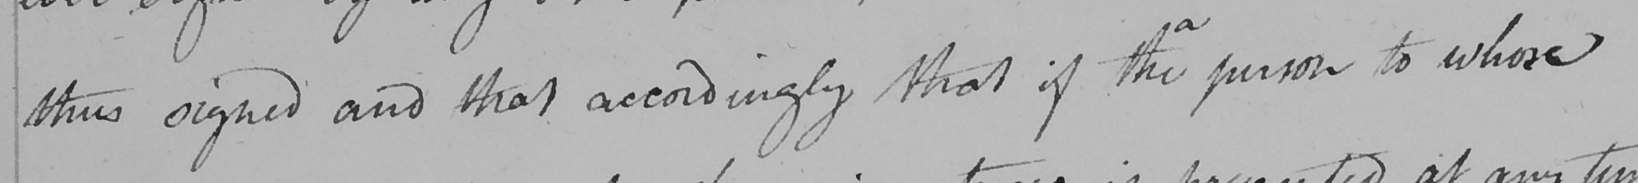Transcribe the text shown in this historical manuscript line. thus signed and that accordingly that if the person to whose 